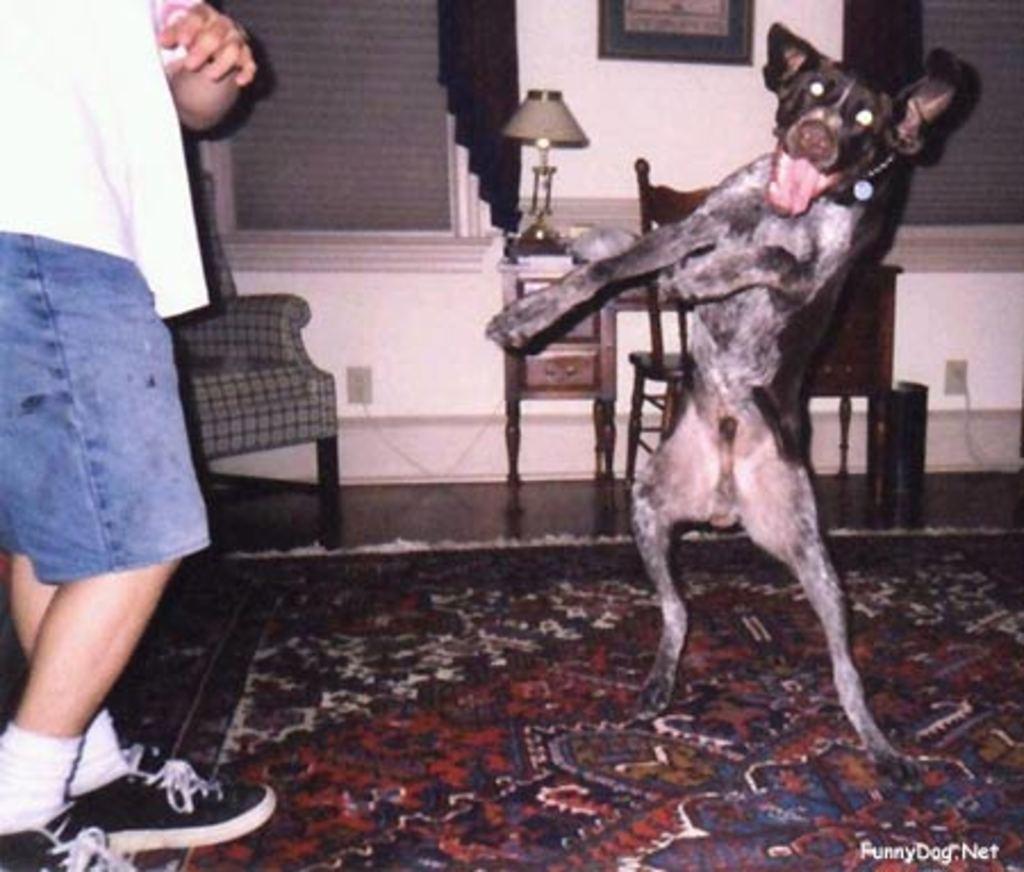How would you summarize this image in a sentence or two? In the left, a person is standing who is half visible. In the right, a dog is standing and lifting front legs up. In the background walls are visible of pink in color. In the middle, table and chair is visible on which lamp is kept. On the top, a wall painting is visible and both side window is visible. This image is taken inside a room. 